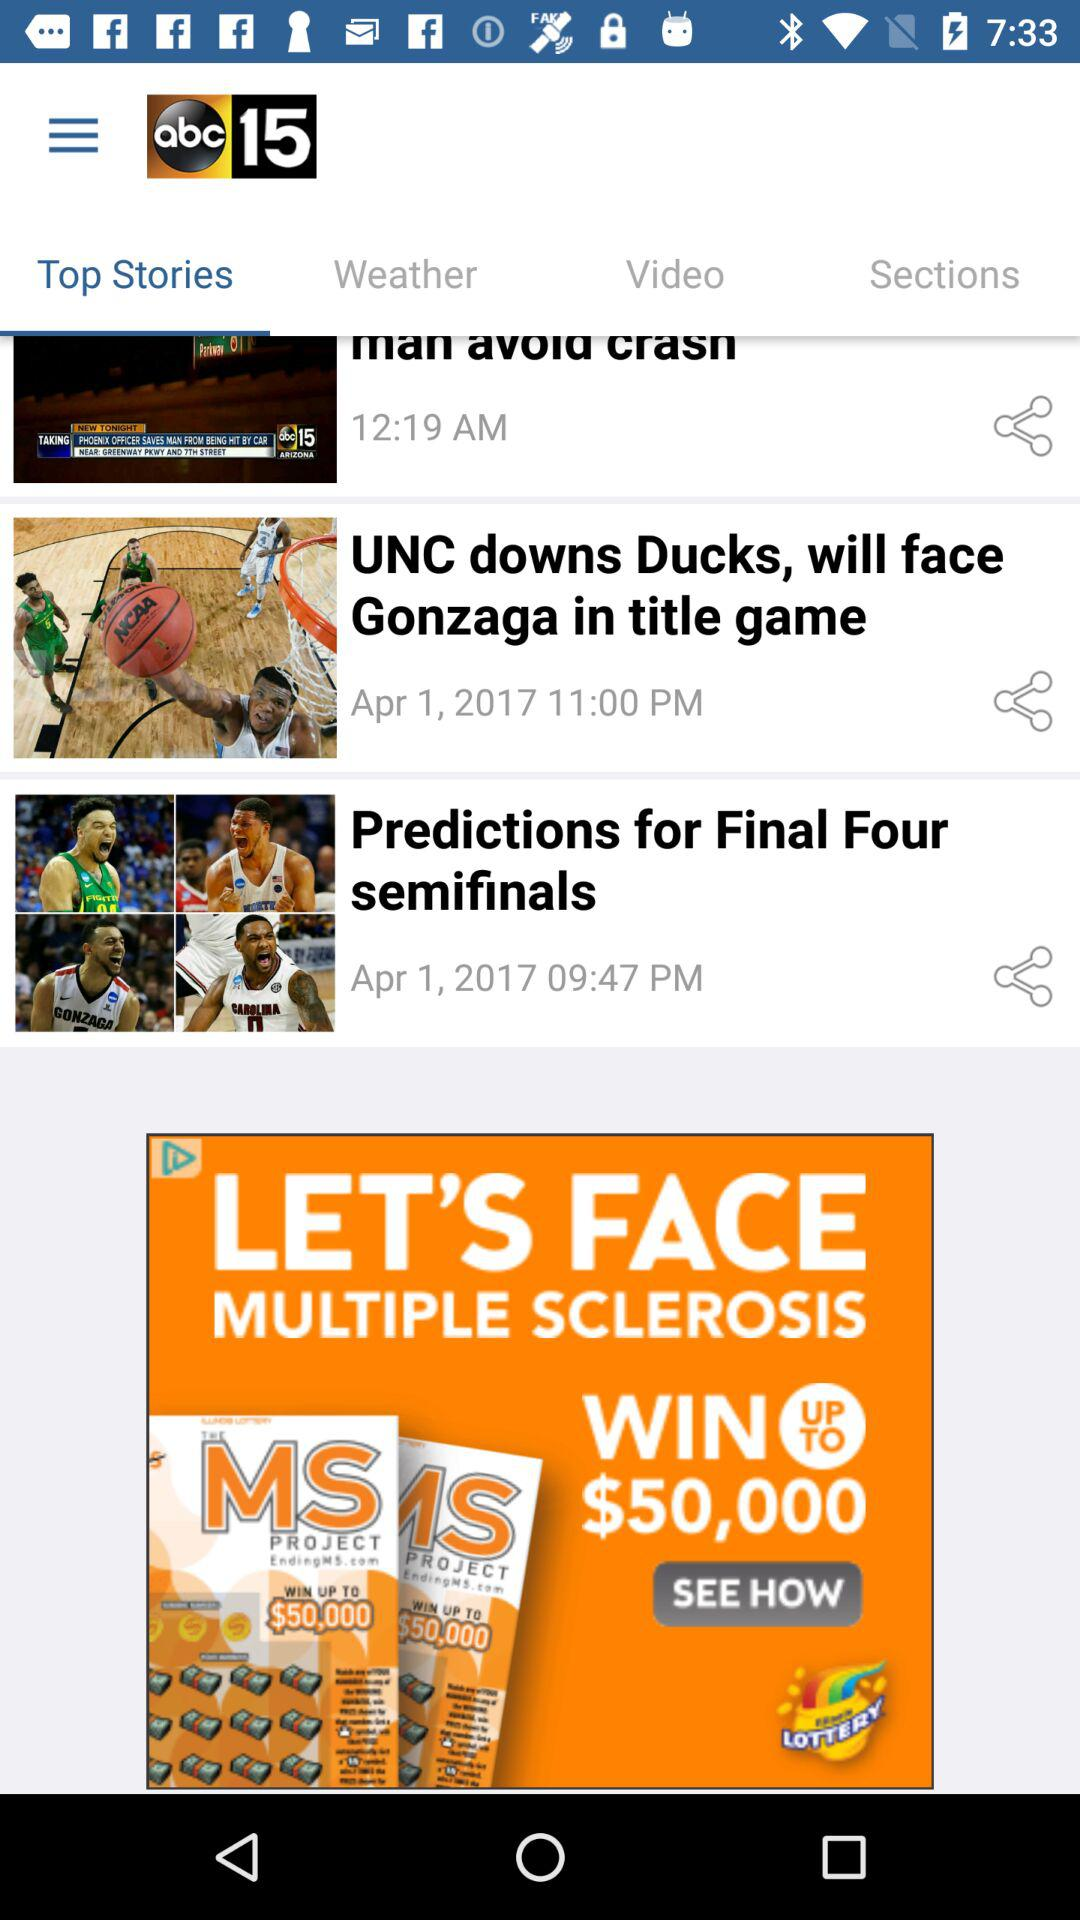Which tab is selected? The selected tab is "Top Stories". 